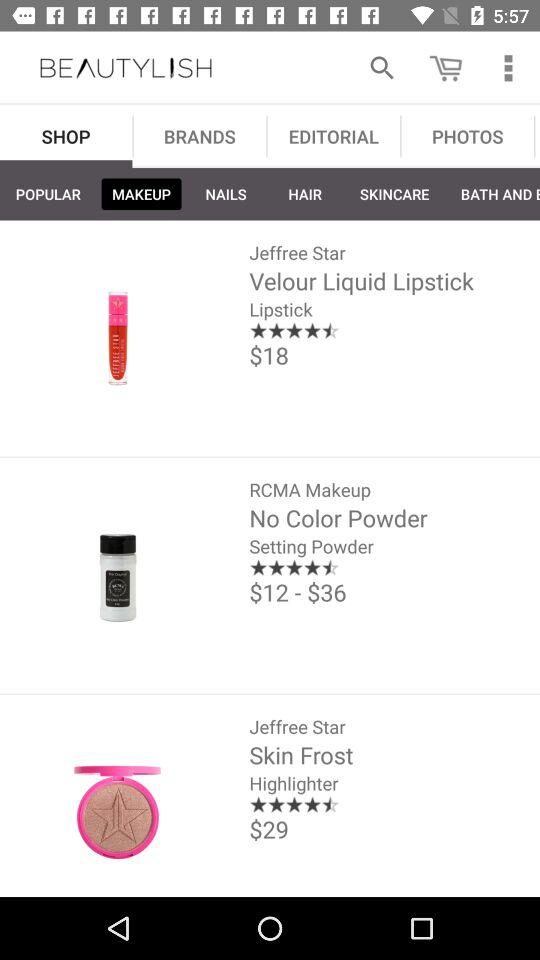What is the rating of setting powder? The rating is 4.5 stars. 